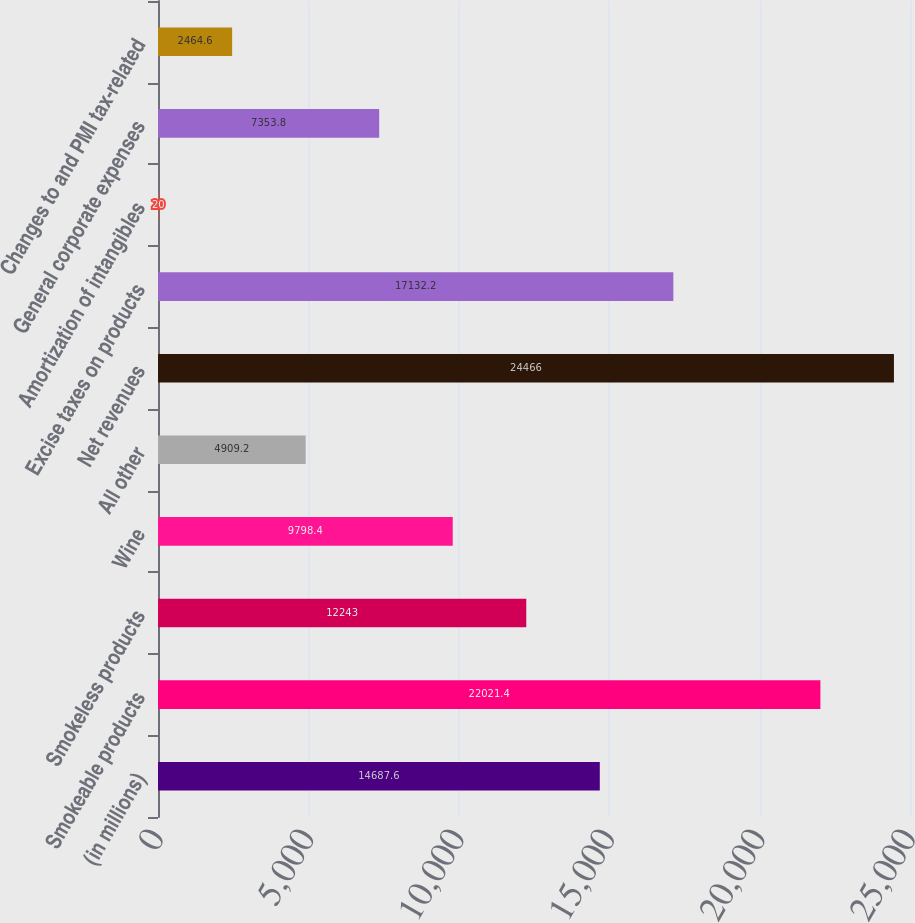Convert chart to OTSL. <chart><loc_0><loc_0><loc_500><loc_500><bar_chart><fcel>(in millions)<fcel>Smokeable products<fcel>Smokeless products<fcel>Wine<fcel>All other<fcel>Net revenues<fcel>Excise taxes on products<fcel>Amortization of intangibles<fcel>General corporate expenses<fcel>Changes to and PMI tax-related<nl><fcel>14687.6<fcel>22021.4<fcel>12243<fcel>9798.4<fcel>4909.2<fcel>24466<fcel>17132.2<fcel>20<fcel>7353.8<fcel>2464.6<nl></chart> 